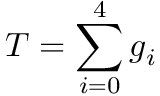Convert formula to latex. <formula><loc_0><loc_0><loc_500><loc_500>T = \sum _ { i = 0 } ^ { 4 } g _ { i }</formula> 